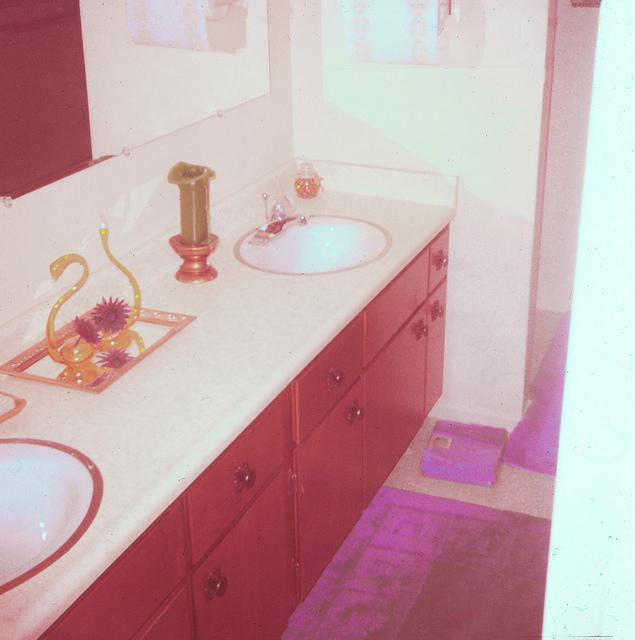Is the countertop cluttered?
Answer briefly. No. What room is pictured?
Keep it brief. Bathroom. What room is this?
Short answer required. Bathroom. Is the toilet clean?
Give a very brief answer. Yes. What pattern is shown on the mats?
Concise answer only. Square. What is the counter made from?
Write a very short answer. Formica. 